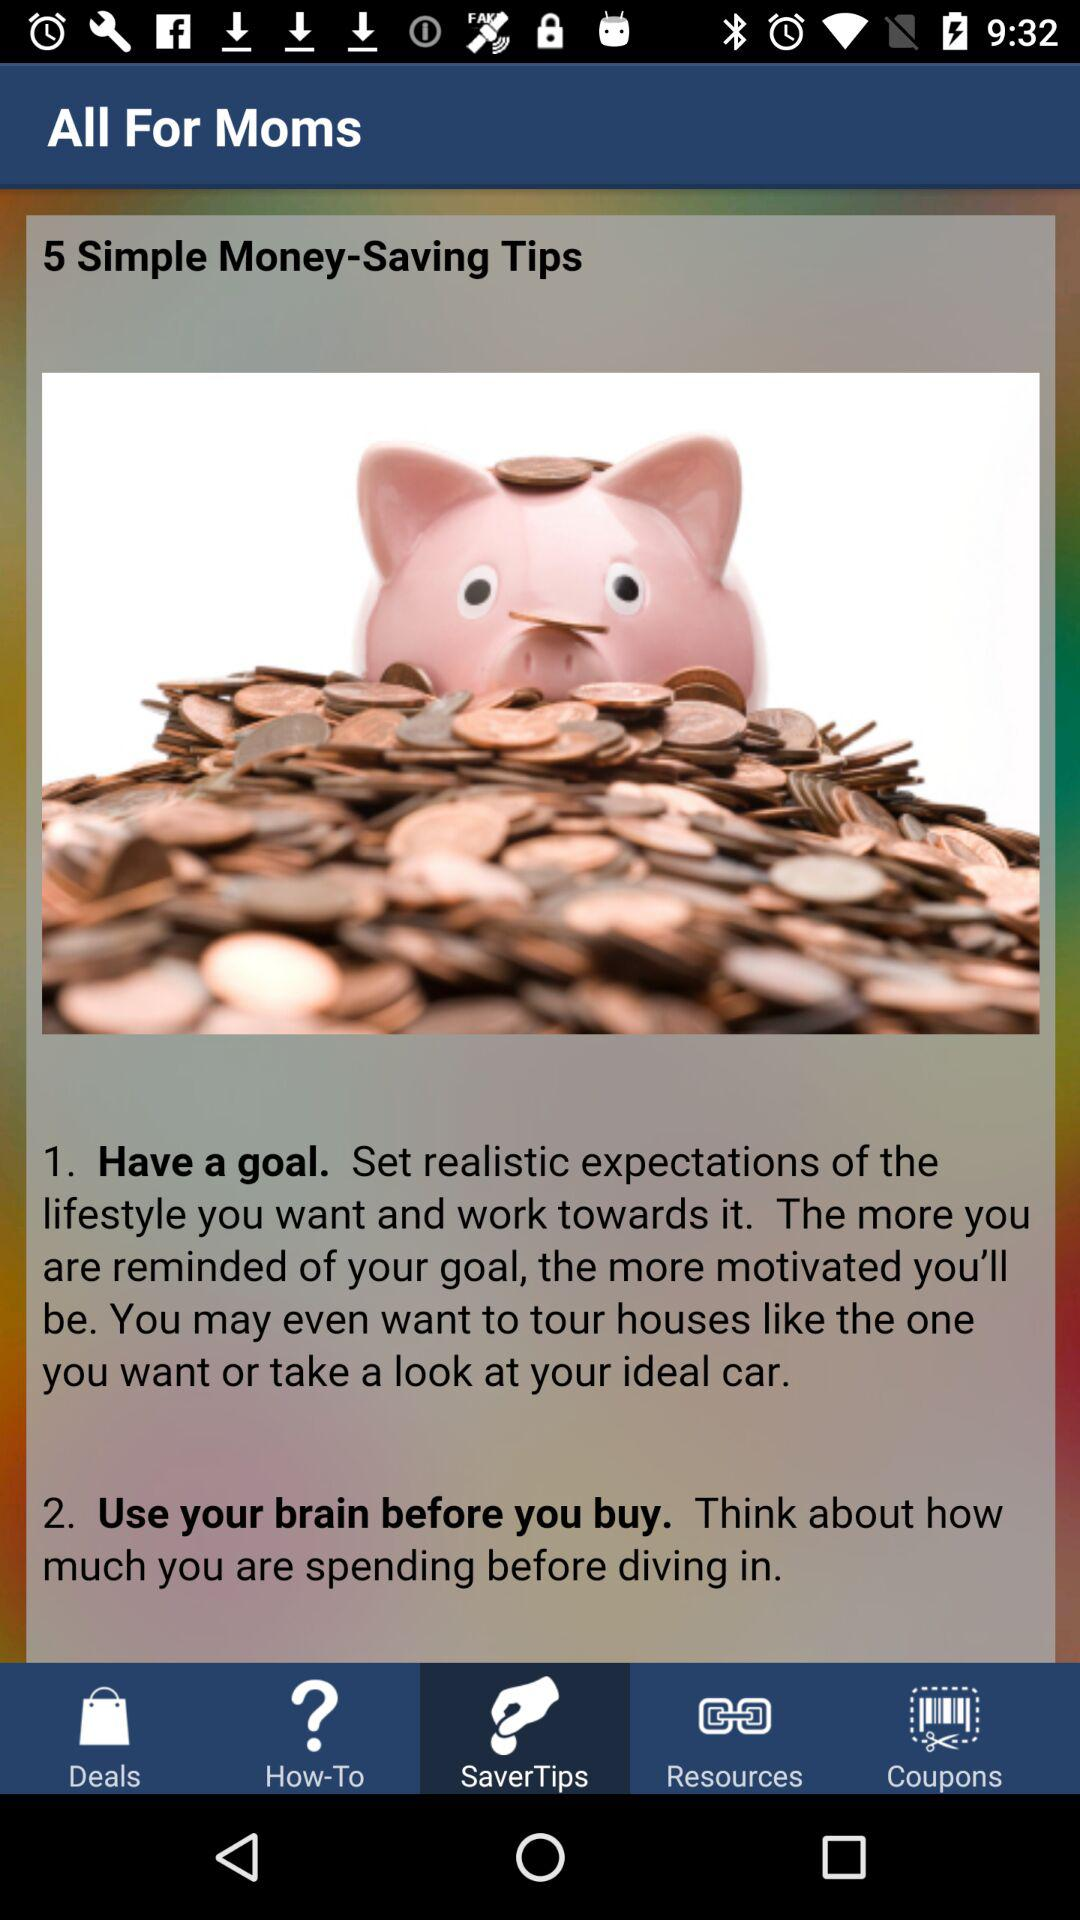Which tab has been selected? The selected tab is "SaverTips". 